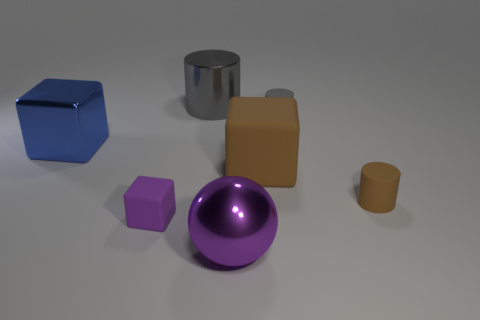Is the large purple metallic thing the same shape as the purple matte object?
Your answer should be very brief. No. How many other objects are the same size as the metal cylinder?
Your answer should be very brief. 3. What number of objects are large objects that are on the right side of the small matte block or metal balls?
Offer a very short reply. 3. What is the color of the large matte cube?
Keep it short and to the point. Brown. There is a large thing that is on the right side of the purple metallic object; what material is it?
Give a very brief answer. Rubber. There is a large brown rubber object; is its shape the same as the big thing that is in front of the tiny purple cube?
Give a very brief answer. No. Are there more small brown matte cylinders than brown objects?
Ensure brevity in your answer.  No. Is there anything else that is the same color as the ball?
Keep it short and to the point. Yes. The tiny brown thing that is the same material as the large brown block is what shape?
Your answer should be compact. Cylinder. What is the block on the right side of the thing in front of the small purple rubber cube made of?
Keep it short and to the point. Rubber. 